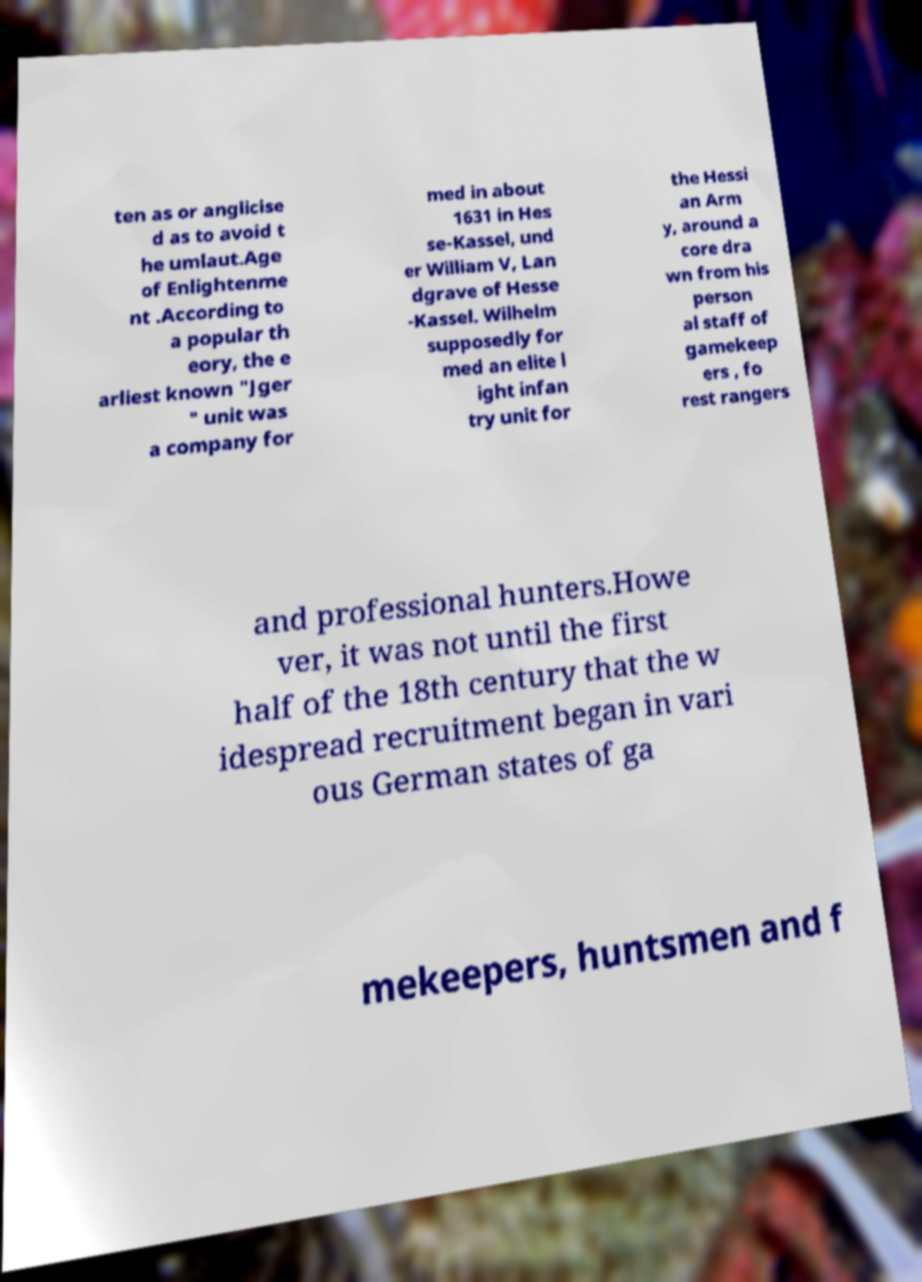Could you assist in decoding the text presented in this image and type it out clearly? ten as or anglicise d as to avoid t he umlaut.Age of Enlightenme nt .According to a popular th eory, the e arliest known "Jger " unit was a company for med in about 1631 in Hes se-Kassel, und er William V, Lan dgrave of Hesse -Kassel. Wilhelm supposedly for med an elite l ight infan try unit for the Hessi an Arm y, around a core dra wn from his person al staff of gamekeep ers , fo rest rangers and professional hunters.Howe ver, it was not until the first half of the 18th century that the w idespread recruitment began in vari ous German states of ga mekeepers, huntsmen and f 